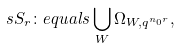<formula> <loc_0><loc_0><loc_500><loc_500>\ s S _ { r } \colon e q u a l s \bigcup _ { W } \Omega _ { W , q ^ { n _ { 0 } r } } ,</formula> 